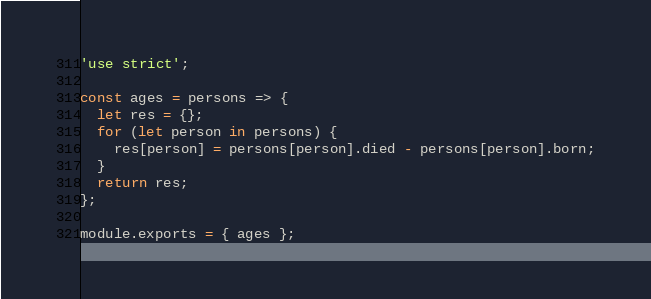Convert code to text. <code><loc_0><loc_0><loc_500><loc_500><_JavaScript_>'use strict';

const ages = persons => {
  let res = {};
  for (let person in persons) {
    res[person] = persons[person].died - persons[person].born;
  }
  return res;
};

module.exports = { ages };
</code> 